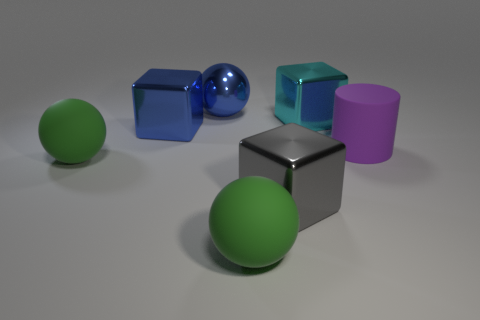Is the ball that is behind the big cylinder made of the same material as the purple cylinder?
Provide a succinct answer. No. There is a large rubber sphere right of the large blue shiny cube; is it the same color as the large rubber thing that is to the left of the blue metallic cube?
Your answer should be compact. Yes. How many cylinders are either brown shiny things or cyan things?
Ensure brevity in your answer.  0. Are there an equal number of large green matte objects that are on the right side of the large cyan shiny object and big gray matte cylinders?
Your answer should be compact. Yes. There is a large ball that is behind the large green rubber thing behind the large cube that is in front of the purple matte object; what is it made of?
Keep it short and to the point. Metal. There is a big cube that is the same color as the shiny sphere; what material is it?
Give a very brief answer. Metal. How many things are either big balls that are to the right of the shiny sphere or purple cylinders?
Give a very brief answer. 2. How many objects are either blue metallic objects or green matte objects that are left of the large blue shiny sphere?
Offer a very short reply. 3. There is a rubber thing that is in front of the large metallic block that is in front of the large purple cylinder; what number of green spheres are left of it?
Provide a succinct answer. 1. There is a gray block that is the same size as the purple rubber cylinder; what is its material?
Ensure brevity in your answer.  Metal. 